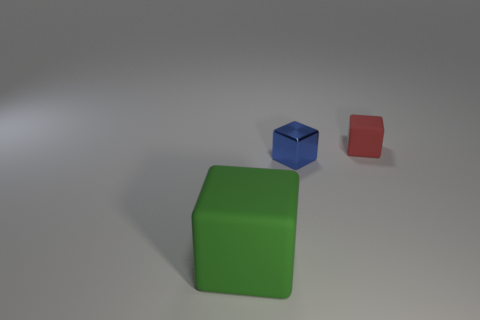Add 3 green rubber objects. How many objects exist? 6 Subtract all matte cubes. Subtract all tiny red rubber cubes. How many objects are left? 0 Add 3 rubber blocks. How many rubber blocks are left? 5 Add 1 blue metal things. How many blue metal things exist? 2 Subtract 0 cyan cylinders. How many objects are left? 3 